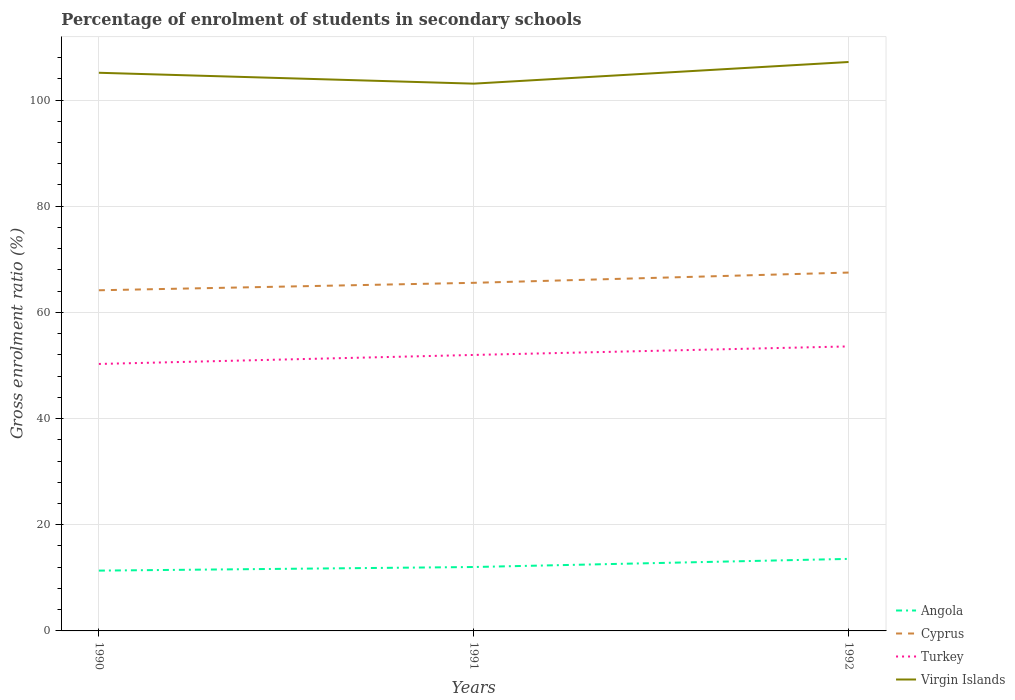Is the number of lines equal to the number of legend labels?
Make the answer very short. Yes. Across all years, what is the maximum percentage of students enrolled in secondary schools in Angola?
Give a very brief answer. 11.36. In which year was the percentage of students enrolled in secondary schools in Cyprus maximum?
Offer a very short reply. 1990. What is the total percentage of students enrolled in secondary schools in Virgin Islands in the graph?
Offer a very short reply. -4.08. What is the difference between the highest and the second highest percentage of students enrolled in secondary schools in Virgin Islands?
Give a very brief answer. 4.08. What is the difference between the highest and the lowest percentage of students enrolled in secondary schools in Virgin Islands?
Offer a very short reply. 2. Does the graph contain any zero values?
Your response must be concise. No. Does the graph contain grids?
Provide a short and direct response. Yes. Where does the legend appear in the graph?
Give a very brief answer. Bottom right. How many legend labels are there?
Provide a short and direct response. 4. What is the title of the graph?
Provide a succinct answer. Percentage of enrolment of students in secondary schools. What is the Gross enrolment ratio (%) in Angola in 1990?
Your answer should be very brief. 11.36. What is the Gross enrolment ratio (%) of Cyprus in 1990?
Make the answer very short. 64.17. What is the Gross enrolment ratio (%) of Turkey in 1990?
Keep it short and to the point. 50.29. What is the Gross enrolment ratio (%) of Virgin Islands in 1990?
Offer a very short reply. 105.13. What is the Gross enrolment ratio (%) in Angola in 1991?
Offer a terse response. 12.04. What is the Gross enrolment ratio (%) of Cyprus in 1991?
Keep it short and to the point. 65.57. What is the Gross enrolment ratio (%) in Turkey in 1991?
Offer a very short reply. 51.98. What is the Gross enrolment ratio (%) of Virgin Islands in 1991?
Your response must be concise. 103.08. What is the Gross enrolment ratio (%) in Angola in 1992?
Provide a succinct answer. 13.57. What is the Gross enrolment ratio (%) in Cyprus in 1992?
Offer a terse response. 67.5. What is the Gross enrolment ratio (%) of Turkey in 1992?
Keep it short and to the point. 53.59. What is the Gross enrolment ratio (%) in Virgin Islands in 1992?
Your answer should be compact. 107.16. Across all years, what is the maximum Gross enrolment ratio (%) of Angola?
Offer a very short reply. 13.57. Across all years, what is the maximum Gross enrolment ratio (%) of Cyprus?
Your answer should be compact. 67.5. Across all years, what is the maximum Gross enrolment ratio (%) in Turkey?
Offer a terse response. 53.59. Across all years, what is the maximum Gross enrolment ratio (%) of Virgin Islands?
Make the answer very short. 107.16. Across all years, what is the minimum Gross enrolment ratio (%) in Angola?
Provide a succinct answer. 11.36. Across all years, what is the minimum Gross enrolment ratio (%) of Cyprus?
Give a very brief answer. 64.17. Across all years, what is the minimum Gross enrolment ratio (%) in Turkey?
Offer a very short reply. 50.29. Across all years, what is the minimum Gross enrolment ratio (%) in Virgin Islands?
Offer a very short reply. 103.08. What is the total Gross enrolment ratio (%) in Angola in the graph?
Offer a very short reply. 36.97. What is the total Gross enrolment ratio (%) of Cyprus in the graph?
Give a very brief answer. 197.23. What is the total Gross enrolment ratio (%) in Turkey in the graph?
Make the answer very short. 155.86. What is the total Gross enrolment ratio (%) in Virgin Islands in the graph?
Keep it short and to the point. 315.38. What is the difference between the Gross enrolment ratio (%) of Angola in 1990 and that in 1991?
Offer a very short reply. -0.68. What is the difference between the Gross enrolment ratio (%) of Cyprus in 1990 and that in 1991?
Provide a succinct answer. -1.4. What is the difference between the Gross enrolment ratio (%) in Turkey in 1990 and that in 1991?
Keep it short and to the point. -1.7. What is the difference between the Gross enrolment ratio (%) in Virgin Islands in 1990 and that in 1991?
Ensure brevity in your answer.  2.05. What is the difference between the Gross enrolment ratio (%) of Angola in 1990 and that in 1992?
Keep it short and to the point. -2.21. What is the difference between the Gross enrolment ratio (%) of Cyprus in 1990 and that in 1992?
Your answer should be very brief. -3.34. What is the difference between the Gross enrolment ratio (%) of Turkey in 1990 and that in 1992?
Make the answer very short. -3.31. What is the difference between the Gross enrolment ratio (%) in Virgin Islands in 1990 and that in 1992?
Provide a succinct answer. -2.03. What is the difference between the Gross enrolment ratio (%) in Angola in 1991 and that in 1992?
Your answer should be compact. -1.53. What is the difference between the Gross enrolment ratio (%) of Cyprus in 1991 and that in 1992?
Offer a terse response. -1.93. What is the difference between the Gross enrolment ratio (%) in Turkey in 1991 and that in 1992?
Offer a terse response. -1.61. What is the difference between the Gross enrolment ratio (%) of Virgin Islands in 1991 and that in 1992?
Your response must be concise. -4.08. What is the difference between the Gross enrolment ratio (%) in Angola in 1990 and the Gross enrolment ratio (%) in Cyprus in 1991?
Your answer should be very brief. -54.21. What is the difference between the Gross enrolment ratio (%) in Angola in 1990 and the Gross enrolment ratio (%) in Turkey in 1991?
Provide a short and direct response. -40.62. What is the difference between the Gross enrolment ratio (%) in Angola in 1990 and the Gross enrolment ratio (%) in Virgin Islands in 1991?
Offer a very short reply. -91.73. What is the difference between the Gross enrolment ratio (%) of Cyprus in 1990 and the Gross enrolment ratio (%) of Turkey in 1991?
Make the answer very short. 12.18. What is the difference between the Gross enrolment ratio (%) in Cyprus in 1990 and the Gross enrolment ratio (%) in Virgin Islands in 1991?
Your response must be concise. -38.92. What is the difference between the Gross enrolment ratio (%) in Turkey in 1990 and the Gross enrolment ratio (%) in Virgin Islands in 1991?
Keep it short and to the point. -52.8. What is the difference between the Gross enrolment ratio (%) of Angola in 1990 and the Gross enrolment ratio (%) of Cyprus in 1992?
Provide a short and direct response. -56.14. What is the difference between the Gross enrolment ratio (%) in Angola in 1990 and the Gross enrolment ratio (%) in Turkey in 1992?
Provide a succinct answer. -42.23. What is the difference between the Gross enrolment ratio (%) of Angola in 1990 and the Gross enrolment ratio (%) of Virgin Islands in 1992?
Your answer should be very brief. -95.8. What is the difference between the Gross enrolment ratio (%) of Cyprus in 1990 and the Gross enrolment ratio (%) of Turkey in 1992?
Keep it short and to the point. 10.57. What is the difference between the Gross enrolment ratio (%) in Cyprus in 1990 and the Gross enrolment ratio (%) in Virgin Islands in 1992?
Make the answer very short. -43. What is the difference between the Gross enrolment ratio (%) in Turkey in 1990 and the Gross enrolment ratio (%) in Virgin Islands in 1992?
Offer a terse response. -56.88. What is the difference between the Gross enrolment ratio (%) of Angola in 1991 and the Gross enrolment ratio (%) of Cyprus in 1992?
Keep it short and to the point. -55.46. What is the difference between the Gross enrolment ratio (%) of Angola in 1991 and the Gross enrolment ratio (%) of Turkey in 1992?
Your answer should be very brief. -41.55. What is the difference between the Gross enrolment ratio (%) in Angola in 1991 and the Gross enrolment ratio (%) in Virgin Islands in 1992?
Provide a succinct answer. -95.12. What is the difference between the Gross enrolment ratio (%) in Cyprus in 1991 and the Gross enrolment ratio (%) in Turkey in 1992?
Your answer should be compact. 11.98. What is the difference between the Gross enrolment ratio (%) in Cyprus in 1991 and the Gross enrolment ratio (%) in Virgin Islands in 1992?
Offer a terse response. -41.59. What is the difference between the Gross enrolment ratio (%) of Turkey in 1991 and the Gross enrolment ratio (%) of Virgin Islands in 1992?
Ensure brevity in your answer.  -55.18. What is the average Gross enrolment ratio (%) of Angola per year?
Keep it short and to the point. 12.32. What is the average Gross enrolment ratio (%) in Cyprus per year?
Keep it short and to the point. 65.74. What is the average Gross enrolment ratio (%) in Turkey per year?
Provide a succinct answer. 51.95. What is the average Gross enrolment ratio (%) of Virgin Islands per year?
Your response must be concise. 105.13. In the year 1990, what is the difference between the Gross enrolment ratio (%) of Angola and Gross enrolment ratio (%) of Cyprus?
Offer a terse response. -52.81. In the year 1990, what is the difference between the Gross enrolment ratio (%) in Angola and Gross enrolment ratio (%) in Turkey?
Your response must be concise. -38.93. In the year 1990, what is the difference between the Gross enrolment ratio (%) in Angola and Gross enrolment ratio (%) in Virgin Islands?
Keep it short and to the point. -93.78. In the year 1990, what is the difference between the Gross enrolment ratio (%) in Cyprus and Gross enrolment ratio (%) in Turkey?
Your answer should be very brief. 13.88. In the year 1990, what is the difference between the Gross enrolment ratio (%) of Cyprus and Gross enrolment ratio (%) of Virgin Islands?
Keep it short and to the point. -40.97. In the year 1990, what is the difference between the Gross enrolment ratio (%) of Turkey and Gross enrolment ratio (%) of Virgin Islands?
Keep it short and to the point. -54.85. In the year 1991, what is the difference between the Gross enrolment ratio (%) of Angola and Gross enrolment ratio (%) of Cyprus?
Offer a terse response. -53.53. In the year 1991, what is the difference between the Gross enrolment ratio (%) of Angola and Gross enrolment ratio (%) of Turkey?
Keep it short and to the point. -39.95. In the year 1991, what is the difference between the Gross enrolment ratio (%) of Angola and Gross enrolment ratio (%) of Virgin Islands?
Your answer should be compact. -91.05. In the year 1991, what is the difference between the Gross enrolment ratio (%) of Cyprus and Gross enrolment ratio (%) of Turkey?
Give a very brief answer. 13.58. In the year 1991, what is the difference between the Gross enrolment ratio (%) of Cyprus and Gross enrolment ratio (%) of Virgin Islands?
Offer a very short reply. -37.52. In the year 1991, what is the difference between the Gross enrolment ratio (%) in Turkey and Gross enrolment ratio (%) in Virgin Islands?
Make the answer very short. -51.1. In the year 1992, what is the difference between the Gross enrolment ratio (%) in Angola and Gross enrolment ratio (%) in Cyprus?
Your response must be concise. -53.93. In the year 1992, what is the difference between the Gross enrolment ratio (%) in Angola and Gross enrolment ratio (%) in Turkey?
Provide a succinct answer. -40.02. In the year 1992, what is the difference between the Gross enrolment ratio (%) of Angola and Gross enrolment ratio (%) of Virgin Islands?
Provide a succinct answer. -93.59. In the year 1992, what is the difference between the Gross enrolment ratio (%) of Cyprus and Gross enrolment ratio (%) of Turkey?
Make the answer very short. 13.91. In the year 1992, what is the difference between the Gross enrolment ratio (%) in Cyprus and Gross enrolment ratio (%) in Virgin Islands?
Offer a terse response. -39.66. In the year 1992, what is the difference between the Gross enrolment ratio (%) of Turkey and Gross enrolment ratio (%) of Virgin Islands?
Offer a terse response. -53.57. What is the ratio of the Gross enrolment ratio (%) of Angola in 1990 to that in 1991?
Your answer should be compact. 0.94. What is the ratio of the Gross enrolment ratio (%) in Cyprus in 1990 to that in 1991?
Your answer should be very brief. 0.98. What is the ratio of the Gross enrolment ratio (%) in Turkey in 1990 to that in 1991?
Give a very brief answer. 0.97. What is the ratio of the Gross enrolment ratio (%) of Virgin Islands in 1990 to that in 1991?
Your response must be concise. 1.02. What is the ratio of the Gross enrolment ratio (%) of Angola in 1990 to that in 1992?
Your answer should be compact. 0.84. What is the ratio of the Gross enrolment ratio (%) in Cyprus in 1990 to that in 1992?
Your answer should be very brief. 0.95. What is the ratio of the Gross enrolment ratio (%) in Turkey in 1990 to that in 1992?
Offer a terse response. 0.94. What is the ratio of the Gross enrolment ratio (%) of Virgin Islands in 1990 to that in 1992?
Your answer should be very brief. 0.98. What is the ratio of the Gross enrolment ratio (%) in Angola in 1991 to that in 1992?
Provide a succinct answer. 0.89. What is the ratio of the Gross enrolment ratio (%) in Cyprus in 1991 to that in 1992?
Provide a short and direct response. 0.97. What is the ratio of the Gross enrolment ratio (%) of Turkey in 1991 to that in 1992?
Offer a terse response. 0.97. What is the ratio of the Gross enrolment ratio (%) in Virgin Islands in 1991 to that in 1992?
Your answer should be very brief. 0.96. What is the difference between the highest and the second highest Gross enrolment ratio (%) of Angola?
Keep it short and to the point. 1.53. What is the difference between the highest and the second highest Gross enrolment ratio (%) of Cyprus?
Ensure brevity in your answer.  1.93. What is the difference between the highest and the second highest Gross enrolment ratio (%) in Turkey?
Keep it short and to the point. 1.61. What is the difference between the highest and the second highest Gross enrolment ratio (%) of Virgin Islands?
Offer a very short reply. 2.03. What is the difference between the highest and the lowest Gross enrolment ratio (%) in Angola?
Offer a terse response. 2.21. What is the difference between the highest and the lowest Gross enrolment ratio (%) of Cyprus?
Your answer should be compact. 3.34. What is the difference between the highest and the lowest Gross enrolment ratio (%) of Turkey?
Offer a very short reply. 3.31. What is the difference between the highest and the lowest Gross enrolment ratio (%) of Virgin Islands?
Your response must be concise. 4.08. 